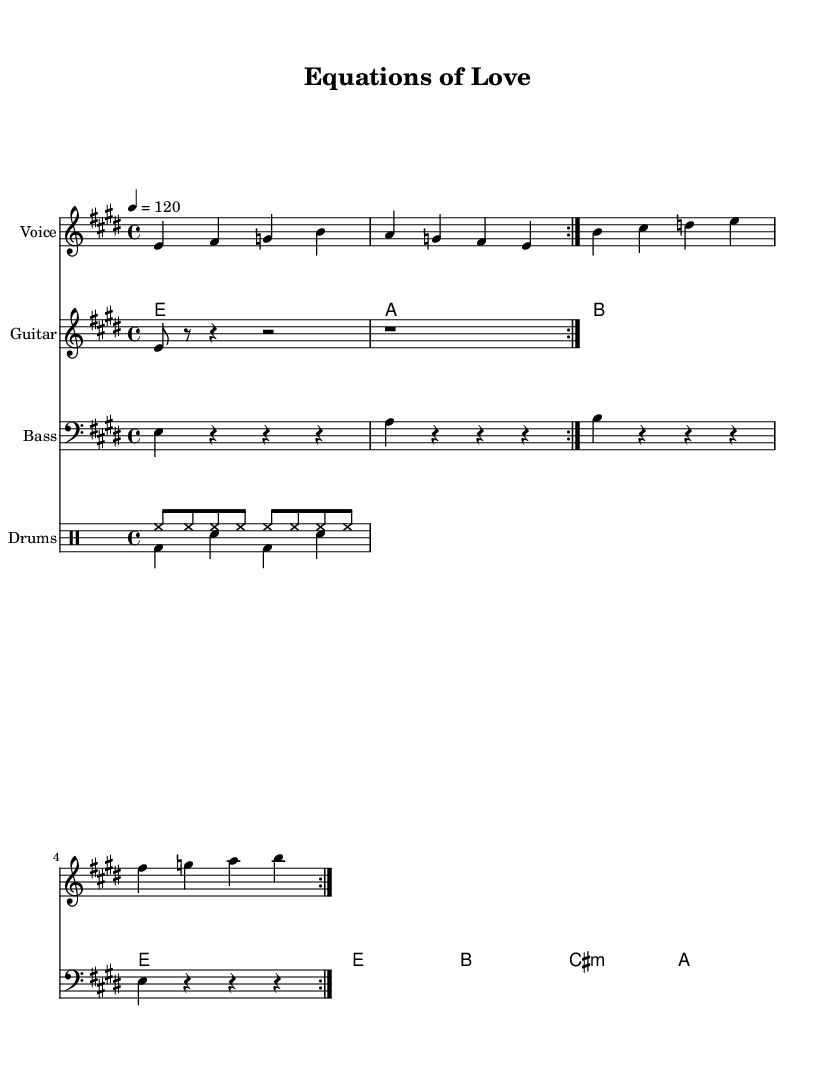What is the key signature of this music? The key signature is E major, indicated by the two sharps, F# and C#.
Answer: E major What is the time signature of this music? The time signature is shown as 4/4, which counts four beats per measure.
Answer: 4/4 What is the tempo marking of the piece? The tempo marking indicates the speed of the piece, set at 120 beats per minute.
Answer: 120 How many measures are in the verse section before it repeats? The verse section has a total of 4 measures before it repeats twice as indicated by the repeat sign.
Answer: 4 What is the instrument specified for the melody? The melody is specified to be played on the Voice staff as indicated at the beginning of the vocal part.
Answer: Voice What chords are used in the first measure of the chorus? The first measure of the chorus contains the notes B, C#, D, and E, which together form the chords for the measures.
Answer: B, C#, D, E How is the bass line structured in terms of rhythm? The bass line consists of quarter notes in the first measure followed by rests, which indicates the rhythmic structure of the music clearly.
Answer: Quarter notes and rests 